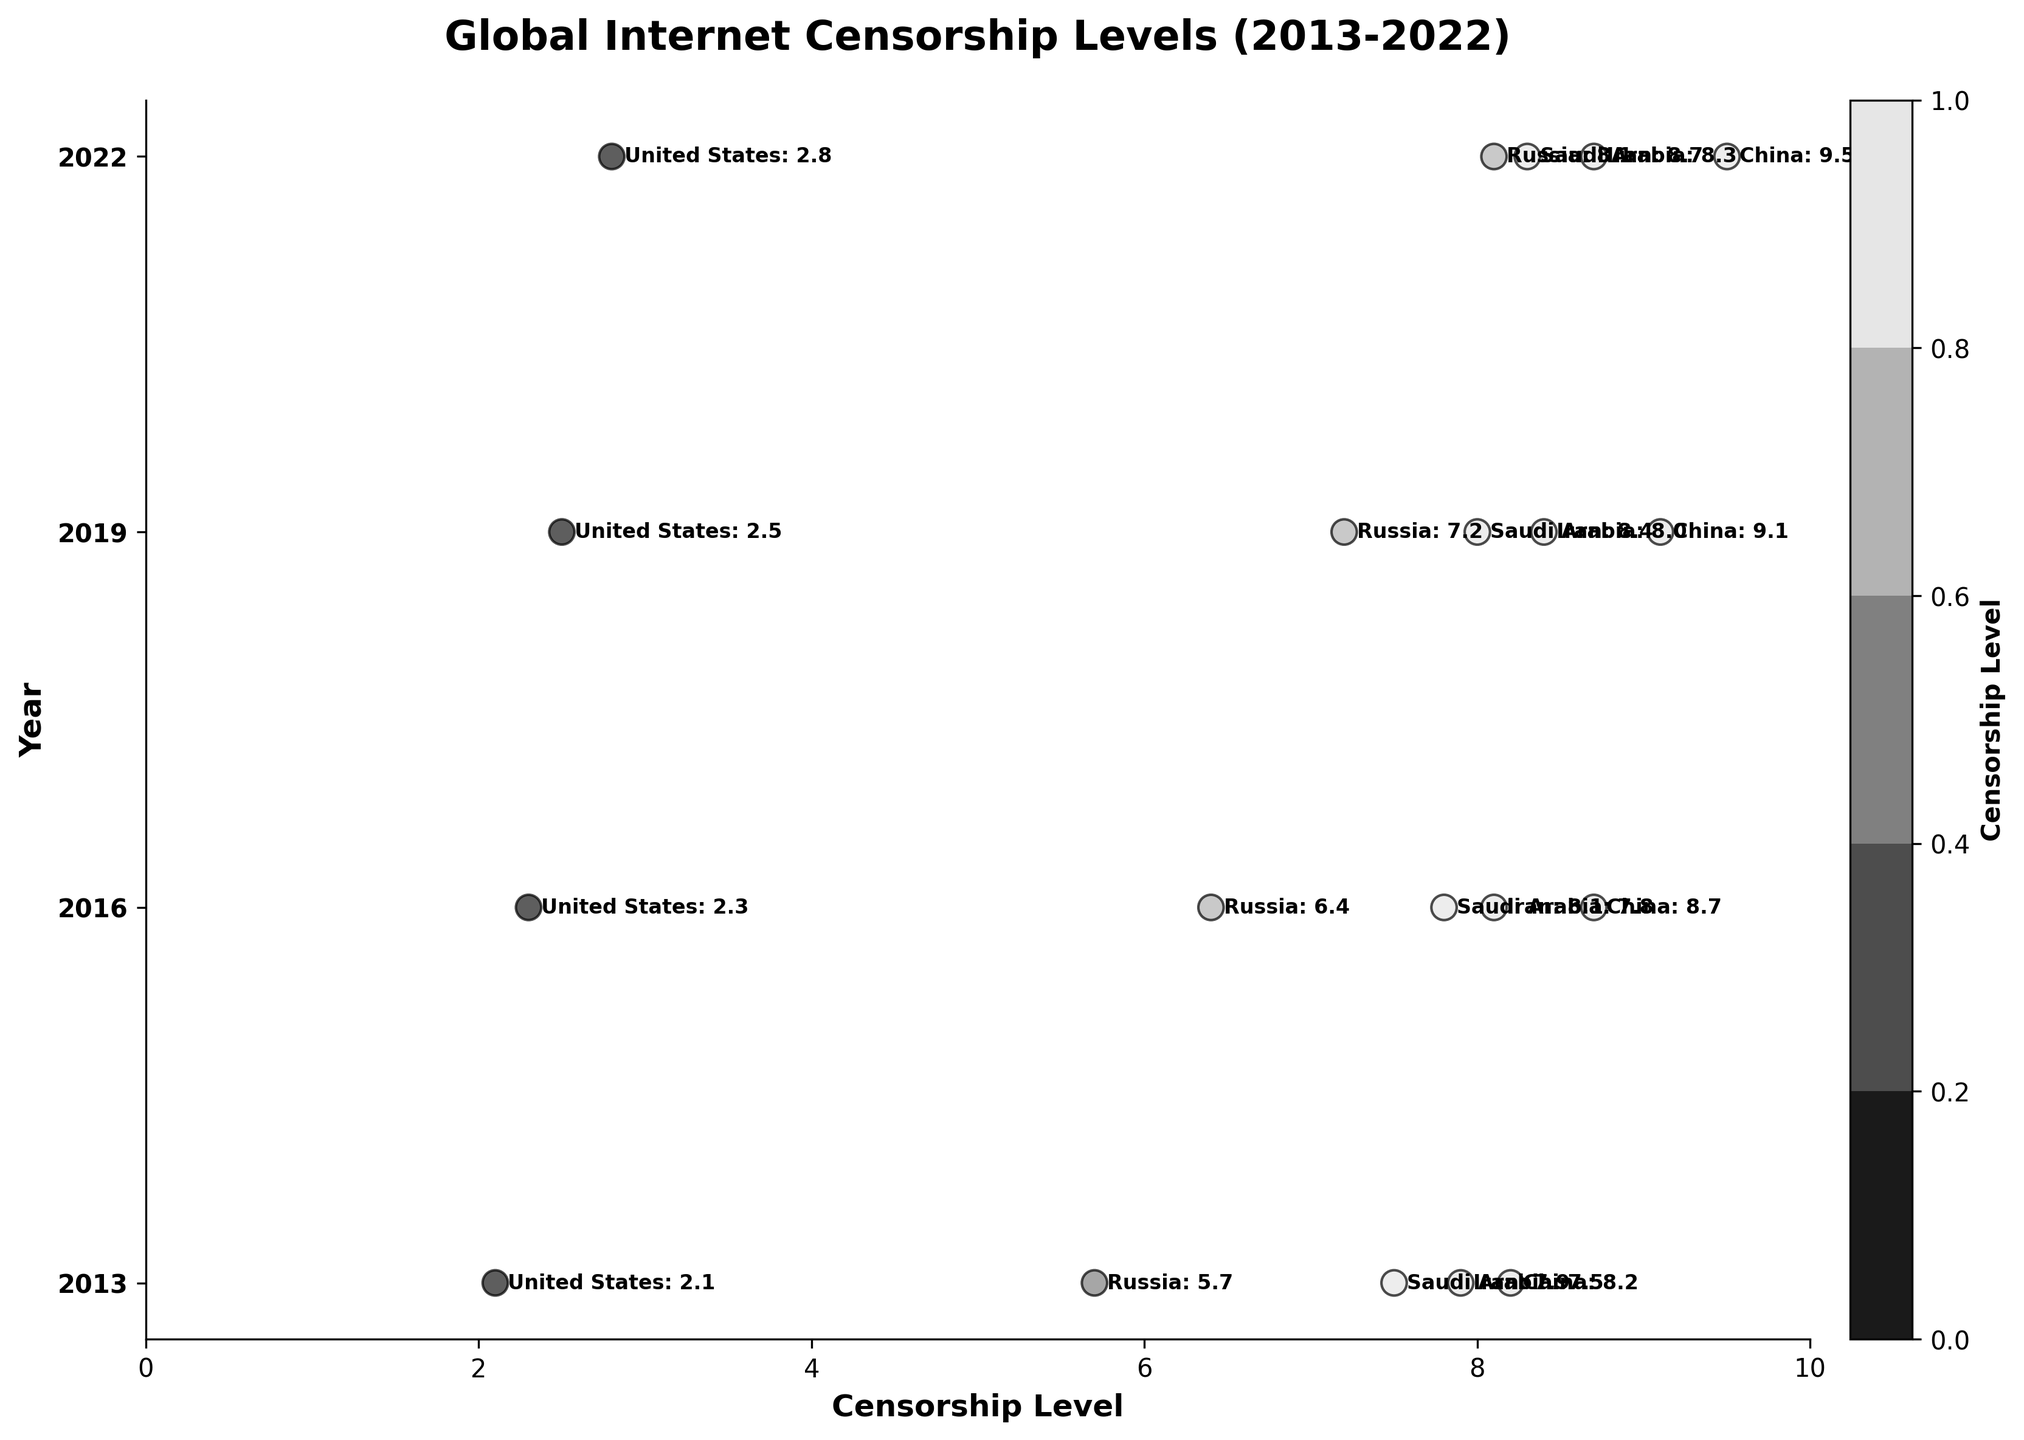What's the title of the figure? The title of the figure is displayed at the top and reads "Global Internet Censorship Levels (2013-2022)."
Answer: Global Internet Censorship Levels (2013-2022) How is the vertical axis labeled? The vertical axis labels each row by the year, indicating that the data spans from 2013 to 2022.
Answer: Year What range of censorship levels is depicted on the horizontal axis? The horizontal axis shows the censorship levels ranging from 0 to 10, with ticks at every 2 units.
Answer: 0 to 10 Which country had the highest internet censorship level in 2013? In 2013, China is shown at the top with a censorship level of 8.2, indicating it had the highest internet censorship level that year.
Answer: China Which country had the lowest internet censorship level in 2022? In 2022, the United States is at the bottom with a censorship level of 2.8, indicating it had the lowest internet censorship level that year.
Answer: United States What is the change in censorship level for China from 2013 to 2022? China's censorship level increased from 8.2 in 2013 to 9.5 in 2022. The change is 9.5 - 8.2 = 1.3.
Answer: 1.3 Compare the censorship levels of Russia and Saudi Arabia in 2019. Which is higher? In 2019, Russia has a censorship level of 7.2, whereas Saudi Arabia has a level of 8.0. Therefore, Saudi Arabia's level is higher.
Answer: Saudi Arabia What is the average censorship level in 2016 across listed countries? For 2016, add the levels for all countries (8.7 + 6.4 + 2.3 + 8.1 + 7.8) which equals 33.3. Divide by the number of countries (5), resulting in an average of 33.3/5 = 6.66.
Answer: 6.66 Did Iran's censorship level increase or decrease from 2013 to 2022? Iran's censorship level increased from 7.9 in 2013 to 8.7 in 2022. Therefore, it increased.
Answer: Increase How many countries had a censorship level above 8.0 in 2022? In 2022, the countries above the censorship level of 8.0 are China, Russia, Iran, and Saudi Arabia. This totals to 4 countries.
Answer: 4 